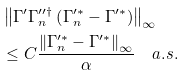<formula> <loc_0><loc_0><loc_500><loc_500>& \left \| \Gamma ^ { \prime } \Gamma _ { n } ^ { \prime \prime \dag } \left ( \Gamma _ { n } ^ { \prime \ast } - \Gamma ^ { \prime \ast } \right ) \right \| _ { \infty } \\ & \leq C \frac { \left \| \Gamma _ { n } ^ { \prime \ast } - \Gamma ^ { \prime \ast } \right \| _ { \infty } } { \alpha } \quad a . s .</formula> 